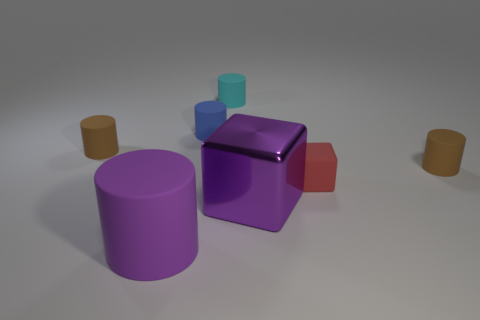The other red thing that is the same shape as the shiny object is what size?
Provide a succinct answer. Small. How many tiny brown cylinders are made of the same material as the purple block?
Offer a terse response. 0. Does the large rubber thing have the same color as the tiny matte thing that is behind the small blue rubber thing?
Provide a succinct answer. No. Are there more cyan matte objects than brown matte cylinders?
Give a very brief answer. No. What color is the big matte cylinder?
Offer a very short reply. Purple. Do the rubber cylinder in front of the big shiny thing and the rubber cube have the same color?
Ensure brevity in your answer.  No. What material is the cylinder that is the same color as the large metal block?
Provide a succinct answer. Rubber. What number of tiny matte cylinders are the same color as the large matte thing?
Your response must be concise. 0. There is a brown rubber object on the right side of the purple cylinder; does it have the same shape as the red object?
Your response must be concise. No. Is the number of big purple metallic cubes behind the cyan cylinder less than the number of red objects in front of the big purple cylinder?
Provide a succinct answer. No. 